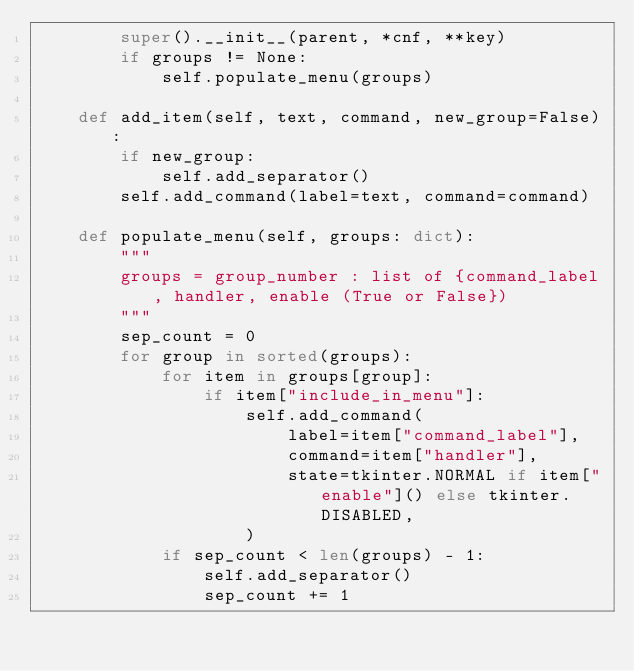Convert code to text. <code><loc_0><loc_0><loc_500><loc_500><_Python_>        super().__init__(parent, *cnf, **key)
        if groups != None:
            self.populate_menu(groups)

    def add_item(self, text, command, new_group=False):
        if new_group:
            self.add_separator()
        self.add_command(label=text, command=command)

    def populate_menu(self, groups: dict):
        """
        groups = group_number : list of {command_label, handler, enable (True or False})
        """
        sep_count = 0
        for group in sorted(groups):
            for item in groups[group]:
                if item["include_in_menu"]:
                    self.add_command(
                        label=item["command_label"],
                        command=item["handler"],
                        state=tkinter.NORMAL if item["enable"]() else tkinter.DISABLED,
                    )
            if sep_count < len(groups) - 1:
                self.add_separator()
                sep_count += 1
</code> 